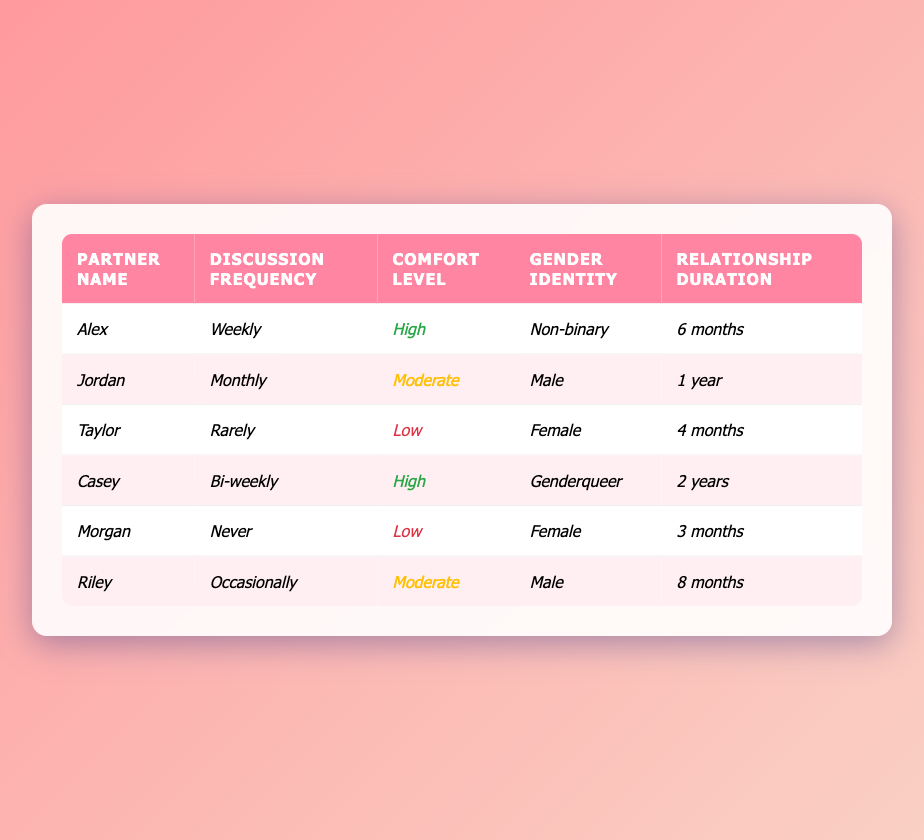What is the discussion frequency for Alex? The table lists the discussion frequency for each partner, and for Alex, it shows "Weekly."
Answer: Weekly How many partners have a high comfort level? By scanning the table, I see two partners (Alex and Casey) marked with a "High" comfort level.
Answer: 2 Which partner has the lowest comfort level? The comfort levels are shown in the table, and the lowest level, "Low," is assigned to Taylor and Morgan.
Answer: Taylor and Morgan What is the relationship duration for Jordan? The table indicates Jordan's relationship duration as "1 year."
Answer: 1 year What is the average relationship duration among all partners? The relationship durations are (6 months, 1 year, 4 months, 2 years, 3 months, and 8 months). Converting them all to months gives (6 + 12 + 4 + 24 + 3 + 8) = 57 months. Dividing by 6 partners gives an average of 57/6 = 9.5 months.
Answer: 9.5 months Is there a partner who never discusses their sexual orientation? The table shows Morgan has a "Never" frequency for discussing sexual orientation. This confirms that there is at least one partner who never discusses this topic.
Answer: Yes Which gender identity corresponds to the partner with the highest frequency of discussion? Looking for the highest frequency, I see that Alex, who is non-binary, discusses their sexual orientation weekly.
Answer: Non-binary Among the partners, who discusses their orientation more frequently: Rely or Morgan? The discussion frequency for Riley is "Occasionally" and for Morgan is "Never." "Occasionally" is more frequent than "Never."
Answer: Riley What is the difference in discussion frequency between Casey and Taylor? Casey discusses their orientation "Bi-weekly," while Taylor discusses "Rarely." To understand the difference, I convert both to a common frequency. Bi-weekly (every two weeks) is more frequent than rarely (few times a year).
Answer: Casey discusses more frequently How many partners have a comfort level rated as moderate? Scanning the table shows that Jordan and Riley are noted as having a "Moderate" comfort level.
Answer: 2 